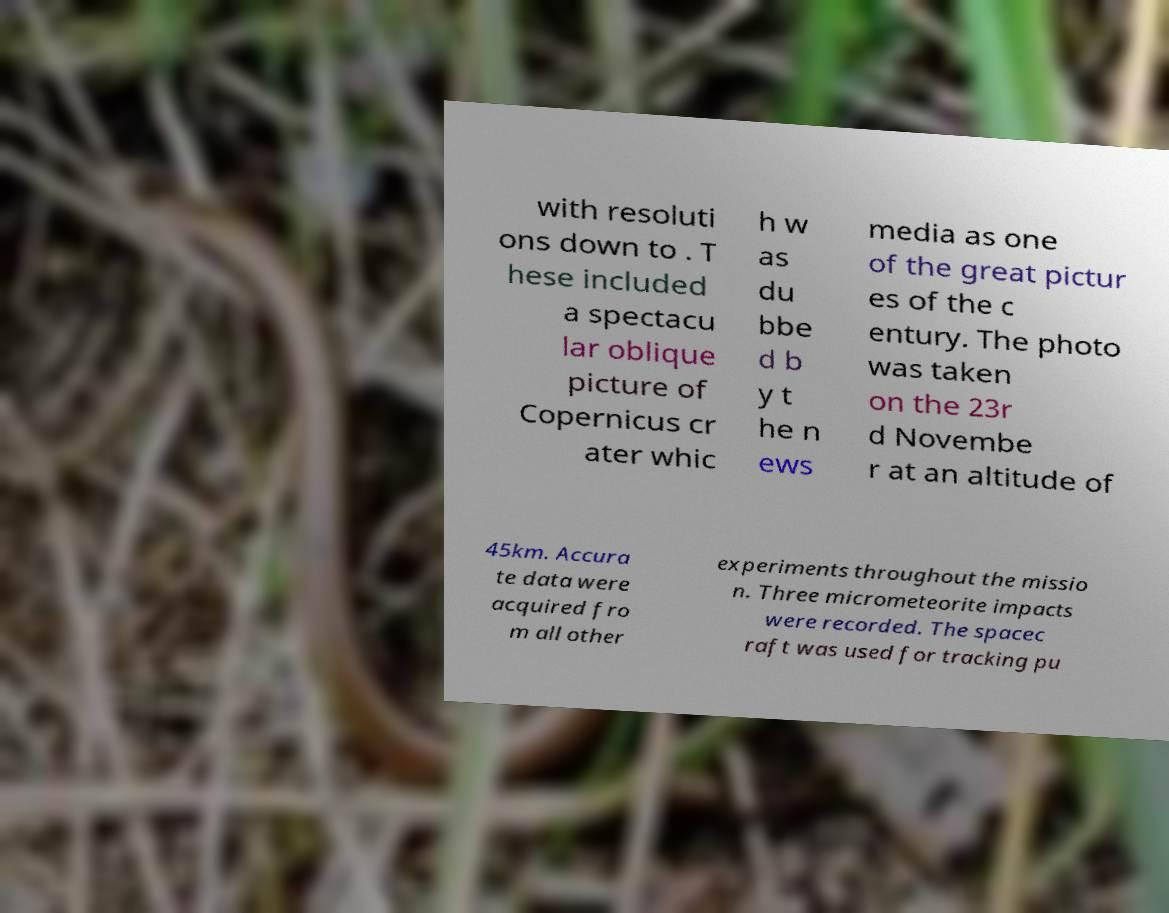Please read and relay the text visible in this image. What does it say? with resoluti ons down to . T hese included a spectacu lar oblique picture of Copernicus cr ater whic h w as du bbe d b y t he n ews media as one of the great pictur es of the c entury. The photo was taken on the 23r d Novembe r at an altitude of 45km. Accura te data were acquired fro m all other experiments throughout the missio n. Three micrometeorite impacts were recorded. The spacec raft was used for tracking pu 